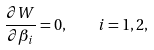<formula> <loc_0><loc_0><loc_500><loc_500>\frac { \partial W } { \partial \beta _ { i } } = 0 , \quad i = 1 , 2 ,</formula> 